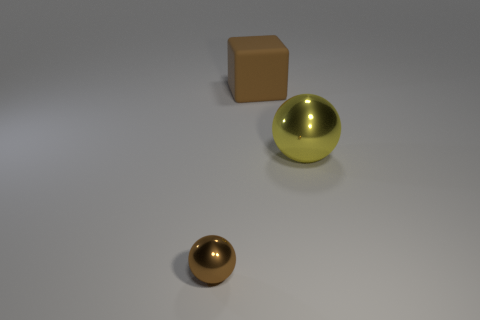Is the material of the large object that is behind the big yellow sphere the same as the small brown object?
Make the answer very short. No. What size is the shiny thing that is to the right of the big brown cube?
Provide a short and direct response. Large. There is a brown object that is on the right side of the tiny brown object; is there a large ball behind it?
Give a very brief answer. No. There is a object in front of the large metallic thing; is its color the same as the object right of the large brown rubber object?
Your answer should be very brief. No. What is the color of the tiny metal thing?
Offer a terse response. Brown. Is there any other thing that is the same color as the small metal thing?
Ensure brevity in your answer.  Yes. What color is the thing that is both in front of the big brown cube and behind the tiny object?
Offer a terse response. Yellow. There is a metallic object that is on the right side of the rubber cube; does it have the same size as the brown ball?
Offer a terse response. No. Is the number of tiny brown objects that are in front of the brown metallic thing greater than the number of yellow rubber cylinders?
Your answer should be very brief. No. Is the tiny brown object the same shape as the large brown thing?
Give a very brief answer. No. 